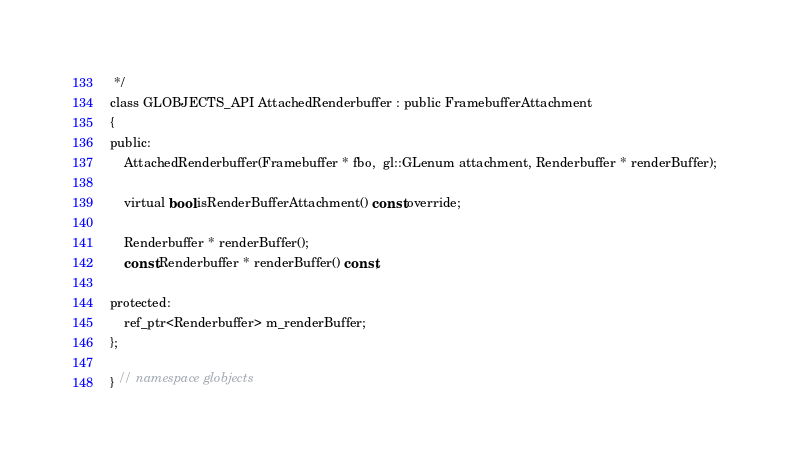<code> <loc_0><loc_0><loc_500><loc_500><_C_> */
class GLOBJECTS_API AttachedRenderbuffer : public FramebufferAttachment
{
public:
    AttachedRenderbuffer(Framebuffer * fbo,  gl::GLenum attachment, Renderbuffer * renderBuffer);

    virtual bool isRenderBufferAttachment() const override;

	Renderbuffer * renderBuffer();
    const Renderbuffer * renderBuffer() const;

protected:
    ref_ptr<Renderbuffer> m_renderBuffer;
};

} // namespace globjects
</code> 